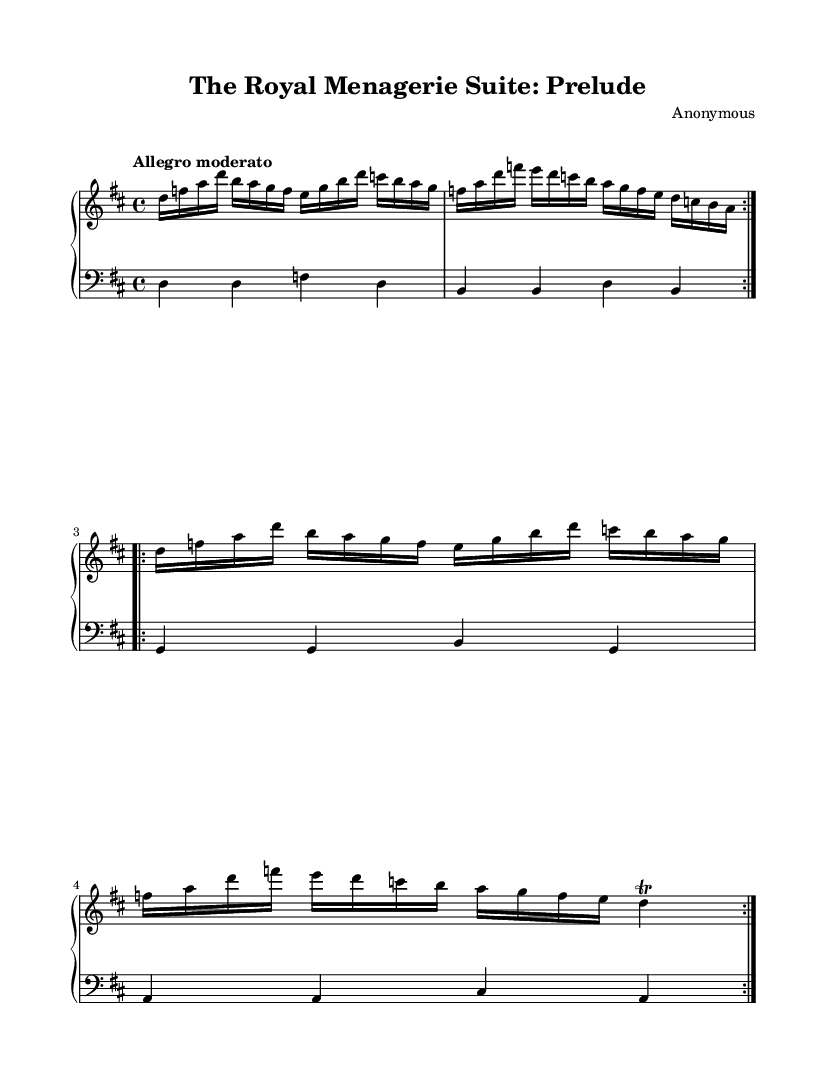What is the key signature of this music? The key signature is D major, which has two sharps (F# and C#). This can be identified in the sheet music by looking at the beginning where the key signature is notated.
Answer: D major What is the time signature of this piece? The time signature is 4/4, which indicates there are four beats in each measure and the quarter note receives one beat. This is noted directly in the music at the beginning of the score.
Answer: 4/4 What is the tempo marking of this music? The tempo marking at the beginning indicates "Allegro moderato," which suggests a moderately fast pace. This can be found in the tempo instructions at the start of the score.
Answer: Allegro moderato How many measures are there in the upper staff? There are four unique measures repeated twice, totaling eight measures shown in the upper staff. The repeat signs indicate that the first section is played again, confirming the total measure count.
Answer: Eight What type of musical form does the upper staff follow? The upper staff follows a binary form, which is evident as it consists of two main sections that are repeated. The presence of repeat signs indicates this structure clearly.
Answer: Binary What is the rhythmic figure used in the upper staff? The rhythmic figure predominantly uses sixteenth notes followed by quarter notes and a trill at the end, which indicates a decorative flourish typical in Baroque music. Each measure’s note types reveal this rhythmic structure.
Answer: Sixteenth notes Which instrumental combination is specified for this piece? The piece is specified for piano, which is indicated by the "PianoStaff" context in the score. This tells the musician that both hands are to be played together as one instrument.
Answer: Piano 